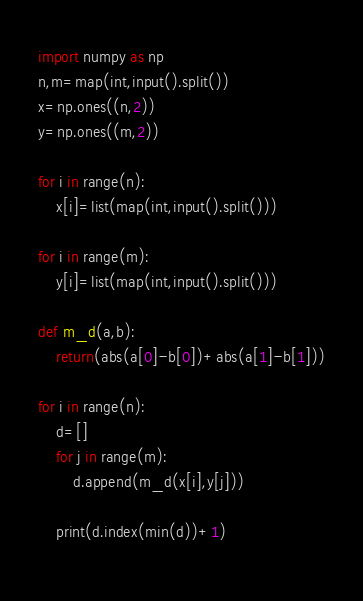<code> <loc_0><loc_0><loc_500><loc_500><_Python_>import numpy as np
n,m=map(int,input().split())
x=np.ones((n,2))
y=np.ones((m,2))

for i in range(n):
    x[i]=list(map(int,input().split()))

for i in range(m):
    y[i]=list(map(int,input().split()))
    
def m_d(a,b):
    return(abs(a[0]-b[0])+abs(a[1]-b[1]))

for i in range(n):
    d=[]
    for j in range(m):
        d.append(m_d(x[i],y[j]))
                 
    print(d.index(min(d))+1)
            </code> 